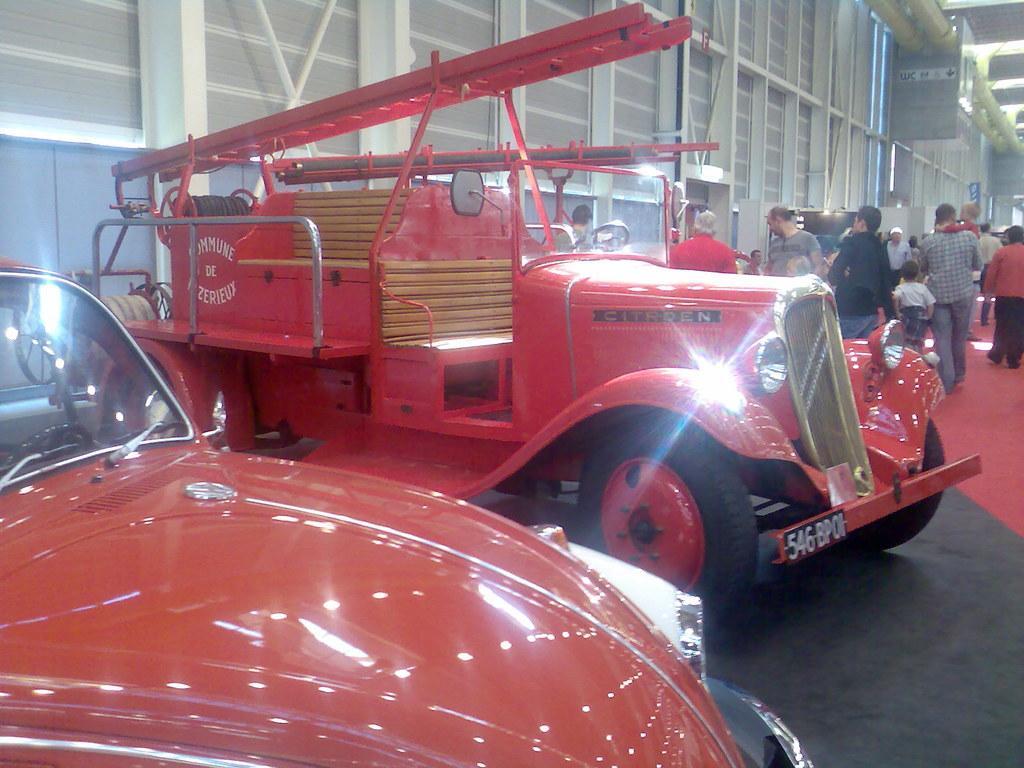How would you summarize this image in a sentence or two? In the picture I can see vehicles on the floor. In the background I can see people standing on the floor. I can also see wall, lights and some other objects. 